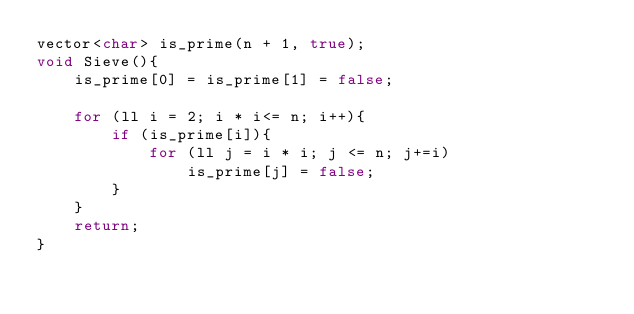<code> <loc_0><loc_0><loc_500><loc_500><_C++_>vector<char> is_prime(n + 1, true);
void Sieve(){
    is_prime[0] = is_prime[1] = false;

    for (ll i = 2; i * i<= n; i++){
        if (is_prime[i]){
            for (ll j = i * i; j <= n; j+=i)
                is_prime[j] = false;
        }
    }
    return;
}
</code> 